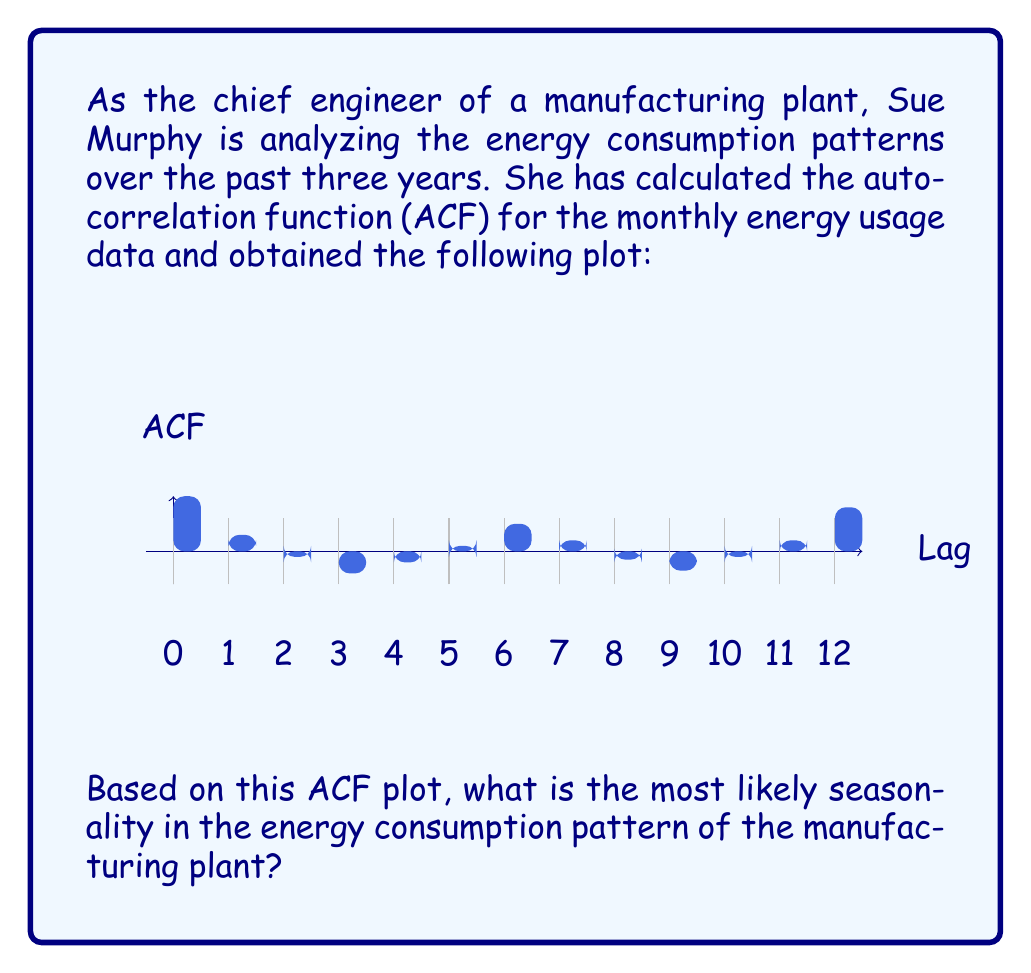Give your solution to this math problem. To determine the seasonality from an ACF plot, we need to look for significant peaks that occur at regular intervals. Here's the step-by-step analysis:

1. The ACF at lag 0 is always 1, which represents the correlation of the series with itself.

2. We observe a notable peak at lag 12, with an ACF value of approximately 0.8. This is the highest peak after lag 0.

3. A peak at lag 12 in monthly data suggests a yearly (12-month) seasonal pattern.

4. To confirm this, we should look for smaller peaks at multiples of the suspected seasonal period. However, the plot only shows up to lag 12, so we can't verify further peaks.

5. The presence of smaller peaks at lags 6 and 7 (about 0.5) could indicate some half-yearly effects, but these are less pronounced than the yearly effect.

6. The alternating positive and negative values between lags 1-11 suggest some shorter-term fluctuations, but these are not as strong or regular as the yearly pattern.

7. In time series analysis, we typically look for the longest, most pronounced regular pattern, which in this case is the yearly cycle.

The ACF plot strongly suggests a 12-month (yearly) seasonality in the energy consumption pattern, which aligns with common business cycles and seasonal changes in manufacturing operations.
Answer: 12-month (yearly) seasonality 